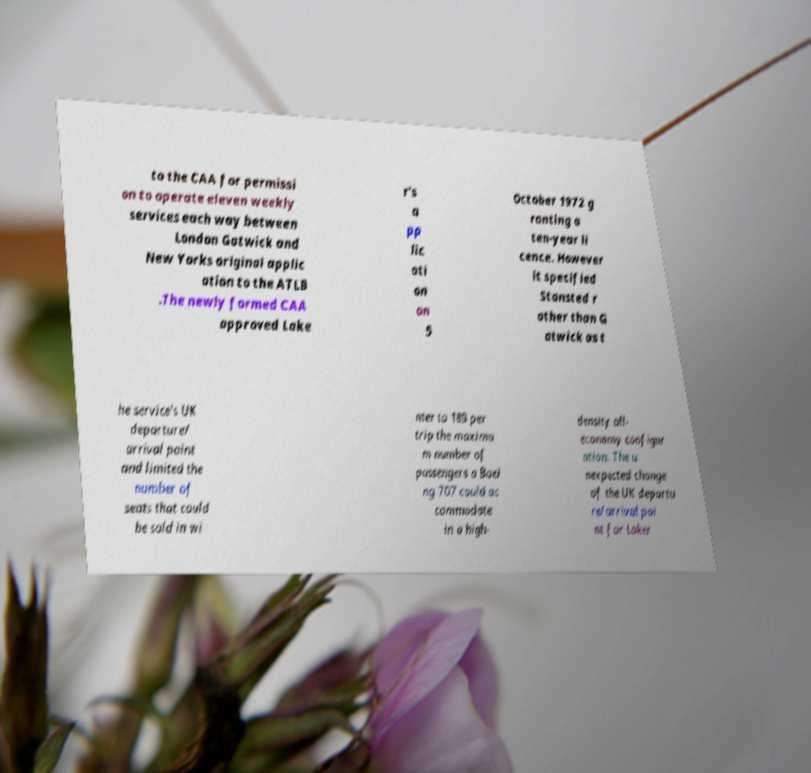Could you extract and type out the text from this image? to the CAA for permissi on to operate eleven weekly services each way between London Gatwick and New Yorks original applic ation to the ATLB .The newly formed CAA approved Lake r's a pp lic ati on on 5 October 1972 g ranting a ten-year li cence. However it specified Stansted r ather than G atwick as t he service's UK departure/ arrival point and limited the number of seats that could be sold in wi nter to 189 per trip the maximu m number of passengers a Boei ng 707 could ac commodate in a high- density all- economy configur ation. The u nexpected change of the UK departu re/arrival poi nt for Laker 